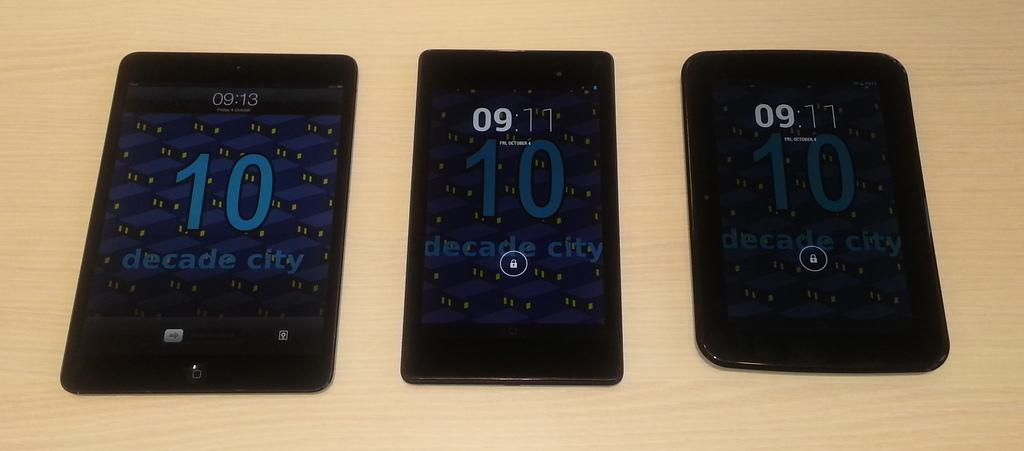<image>
Present a compact description of the photo's key features. The cell phone on the left says the time is 09:13. 